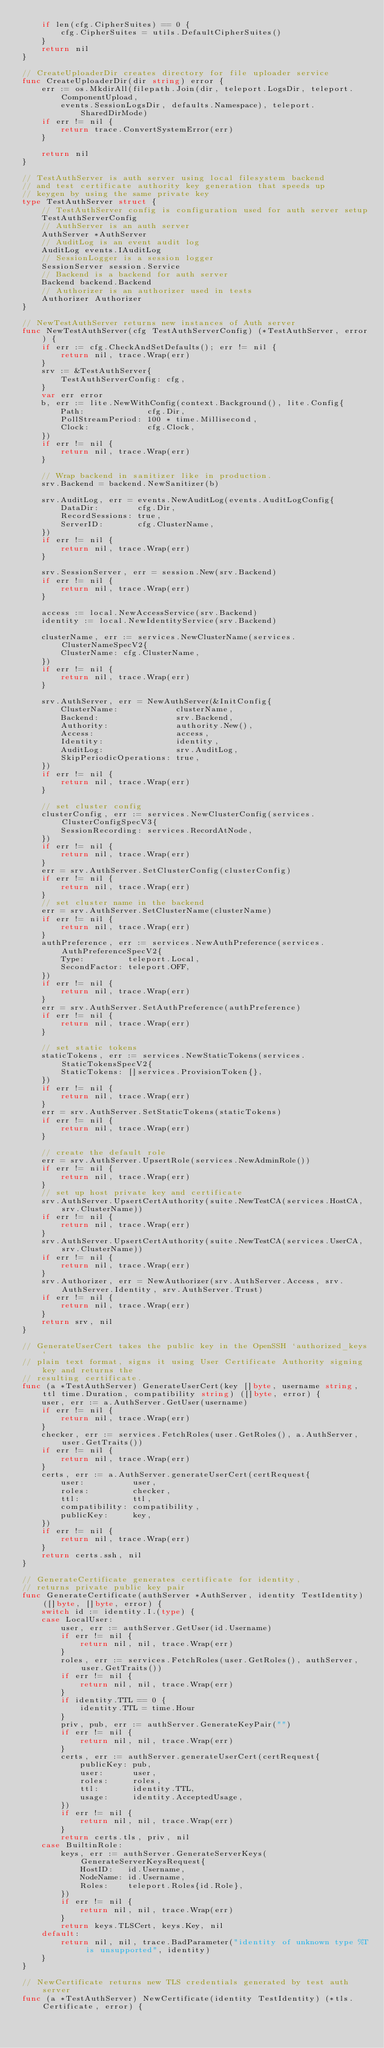Convert code to text. <code><loc_0><loc_0><loc_500><loc_500><_Go_>	if len(cfg.CipherSuites) == 0 {
		cfg.CipherSuites = utils.DefaultCipherSuites()
	}
	return nil
}

// CreateUploaderDir creates directory for file uploader service
func CreateUploaderDir(dir string) error {
	err := os.MkdirAll(filepath.Join(dir, teleport.LogsDir, teleport.ComponentUpload,
		events.SessionLogsDir, defaults.Namespace), teleport.SharedDirMode)
	if err != nil {
		return trace.ConvertSystemError(err)
	}

	return nil
}

// TestAuthServer is auth server using local filesystem backend
// and test certificate authority key generation that speeds up
// keygen by using the same private key
type TestAuthServer struct {
	// TestAuthServer config is configuration used for auth server setup
	TestAuthServerConfig
	// AuthServer is an auth server
	AuthServer *AuthServer
	// AuditLog is an event audit log
	AuditLog events.IAuditLog
	// SessionLogger is a session logger
	SessionServer session.Service
	// Backend is a backend for auth server
	Backend backend.Backend
	// Authorizer is an authorizer used in tests
	Authorizer Authorizer
}

// NewTestAuthServer returns new instances of Auth server
func NewTestAuthServer(cfg TestAuthServerConfig) (*TestAuthServer, error) {
	if err := cfg.CheckAndSetDefaults(); err != nil {
		return nil, trace.Wrap(err)
	}
	srv := &TestAuthServer{
		TestAuthServerConfig: cfg,
	}
	var err error
	b, err := lite.NewWithConfig(context.Background(), lite.Config{
		Path:             cfg.Dir,
		PollStreamPeriod: 100 * time.Millisecond,
		Clock:            cfg.Clock,
	})
	if err != nil {
		return nil, trace.Wrap(err)
	}

	// Wrap backend in sanitizer like in production.
	srv.Backend = backend.NewSanitizer(b)

	srv.AuditLog, err = events.NewAuditLog(events.AuditLogConfig{
		DataDir:        cfg.Dir,
		RecordSessions: true,
		ServerID:       cfg.ClusterName,
	})
	if err != nil {
		return nil, trace.Wrap(err)
	}

	srv.SessionServer, err = session.New(srv.Backend)
	if err != nil {
		return nil, trace.Wrap(err)
	}

	access := local.NewAccessService(srv.Backend)
	identity := local.NewIdentityService(srv.Backend)

	clusterName, err := services.NewClusterName(services.ClusterNameSpecV2{
		ClusterName: cfg.ClusterName,
	})
	if err != nil {
		return nil, trace.Wrap(err)
	}

	srv.AuthServer, err = NewAuthServer(&InitConfig{
		ClusterName:            clusterName,
		Backend:                srv.Backend,
		Authority:              authority.New(),
		Access:                 access,
		Identity:               identity,
		AuditLog:               srv.AuditLog,
		SkipPeriodicOperations: true,
	})
	if err != nil {
		return nil, trace.Wrap(err)
	}

	// set cluster config
	clusterConfig, err := services.NewClusterConfig(services.ClusterConfigSpecV3{
		SessionRecording: services.RecordAtNode,
	})
	if err != nil {
		return nil, trace.Wrap(err)
	}
	err = srv.AuthServer.SetClusterConfig(clusterConfig)
	if err != nil {
		return nil, trace.Wrap(err)
	}
	// set cluster name in the backend
	err = srv.AuthServer.SetClusterName(clusterName)
	if err != nil {
		return nil, trace.Wrap(err)
	}
	authPreference, err := services.NewAuthPreference(services.AuthPreferenceSpecV2{
		Type:         teleport.Local,
		SecondFactor: teleport.OFF,
	})
	if err != nil {
		return nil, trace.Wrap(err)
	}
	err = srv.AuthServer.SetAuthPreference(authPreference)
	if err != nil {
		return nil, trace.Wrap(err)
	}

	// set static tokens
	staticTokens, err := services.NewStaticTokens(services.StaticTokensSpecV2{
		StaticTokens: []services.ProvisionToken{},
	})
	if err != nil {
		return nil, trace.Wrap(err)
	}
	err = srv.AuthServer.SetStaticTokens(staticTokens)
	if err != nil {
		return nil, trace.Wrap(err)
	}

	// create the default role
	err = srv.AuthServer.UpsertRole(services.NewAdminRole())
	if err != nil {
		return nil, trace.Wrap(err)
	}
	// set up host private key and certificate
	srv.AuthServer.UpsertCertAuthority(suite.NewTestCA(services.HostCA, srv.ClusterName))
	if err != nil {
		return nil, trace.Wrap(err)
	}
	srv.AuthServer.UpsertCertAuthority(suite.NewTestCA(services.UserCA, srv.ClusterName))
	if err != nil {
		return nil, trace.Wrap(err)
	}
	srv.Authorizer, err = NewAuthorizer(srv.AuthServer.Access, srv.AuthServer.Identity, srv.AuthServer.Trust)
	if err != nil {
		return nil, trace.Wrap(err)
	}
	return srv, nil
}

// GenerateUserCert takes the public key in the OpenSSH `authorized_keys`
// plain text format, signs it using User Certificate Authority signing key and returns the
// resulting certificate.
func (a *TestAuthServer) GenerateUserCert(key []byte, username string, ttl time.Duration, compatibility string) ([]byte, error) {
	user, err := a.AuthServer.GetUser(username)
	if err != nil {
		return nil, trace.Wrap(err)
	}
	checker, err := services.FetchRoles(user.GetRoles(), a.AuthServer, user.GetTraits())
	if err != nil {
		return nil, trace.Wrap(err)
	}
	certs, err := a.AuthServer.generateUserCert(certRequest{
		user:          user,
		roles:         checker,
		ttl:           ttl,
		compatibility: compatibility,
		publicKey:     key,
	})
	if err != nil {
		return nil, trace.Wrap(err)
	}
	return certs.ssh, nil
}

// GenerateCertificate generates certificate for identity,
// returns private public key pair
func GenerateCertificate(authServer *AuthServer, identity TestIdentity) ([]byte, []byte, error) {
	switch id := identity.I.(type) {
	case LocalUser:
		user, err := authServer.GetUser(id.Username)
		if err != nil {
			return nil, nil, trace.Wrap(err)
		}
		roles, err := services.FetchRoles(user.GetRoles(), authServer, user.GetTraits())
		if err != nil {
			return nil, nil, trace.Wrap(err)
		}
		if identity.TTL == 0 {
			identity.TTL = time.Hour
		}
		priv, pub, err := authServer.GenerateKeyPair("")
		if err != nil {
			return nil, nil, trace.Wrap(err)
		}
		certs, err := authServer.generateUserCert(certRequest{
			publicKey: pub,
			user:      user,
			roles:     roles,
			ttl:       identity.TTL,
			usage:     identity.AcceptedUsage,
		})
		if err != nil {
			return nil, nil, trace.Wrap(err)
		}
		return certs.tls, priv, nil
	case BuiltinRole:
		keys, err := authServer.GenerateServerKeys(GenerateServerKeysRequest{
			HostID:   id.Username,
			NodeName: id.Username,
			Roles:    teleport.Roles{id.Role},
		})
		if err != nil {
			return nil, nil, trace.Wrap(err)
		}
		return keys.TLSCert, keys.Key, nil
	default:
		return nil, nil, trace.BadParameter("identity of unknown type %T is unsupported", identity)
	}
}

// NewCertificate returns new TLS credentials generated by test auth server
func (a *TestAuthServer) NewCertificate(identity TestIdentity) (*tls.Certificate, error) {</code> 